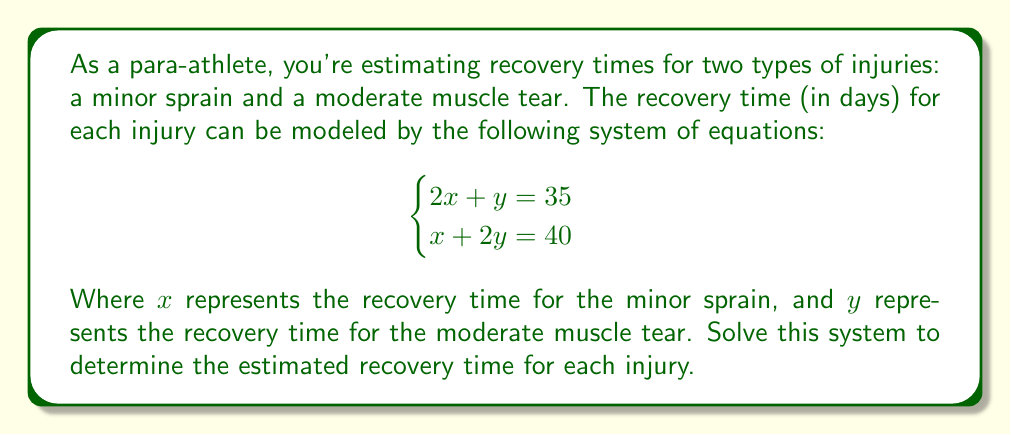Solve this math problem. To solve this system of equations, we'll use the substitution method:

1) From the first equation, express $y$ in terms of $x$:
   $$2x + y = 35$$
   $$y = 35 - 2x$$

2) Substitute this expression for $y$ into the second equation:
   $$x + 2(35 - 2x) = 40$$

3) Simplify:
   $$x + 70 - 4x = 40$$
   $$70 - 3x = 40$$

4) Solve for $x$:
   $$-3x = -30$$
   $$x = 10$$

5) Now that we know $x$, substitute it back into the equation from step 1 to find $y$:
   $$y = 35 - 2(10)$$
   $$y = 35 - 20 = 15$$

Therefore, the estimated recovery time for the minor sprain ($x$) is 10 days, and for the moderate muscle tear ($y$) is 15 days.
Answer: $x = 10$ days, $y = 15$ days 